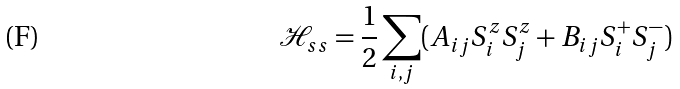Convert formula to latex. <formula><loc_0><loc_0><loc_500><loc_500>\mathcal { H } _ { s s } = \frac { 1 } { 2 } \sum _ { i , j } ( A _ { i j } S _ { i } ^ { z } S _ { j } ^ { z } + B _ { i j } S _ { i } ^ { + } S _ { j } ^ { - } )</formula> 